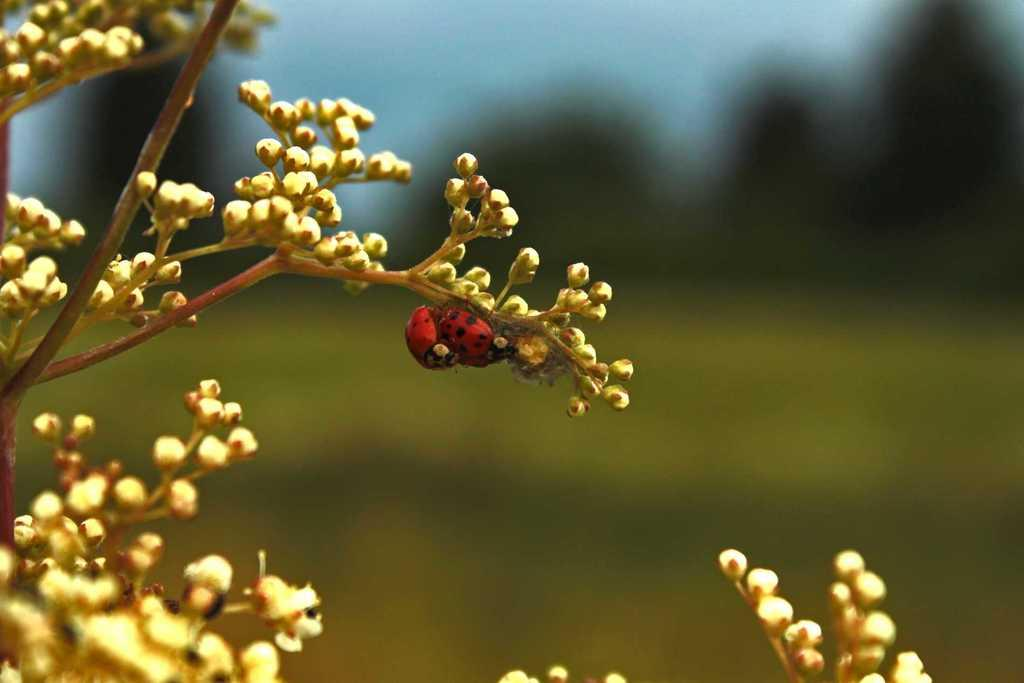What is present in the image? There is a plant in the image. Can you describe the plant further? There is a bee on the plant. What can be observed about the background of the image? The background of the image is blurry. How many holes are visible in the plant in the image? There are no holes visible in the plant in the image. What type of hair can be seen on the bee in the image? There is no hair present on the bee in the image. 